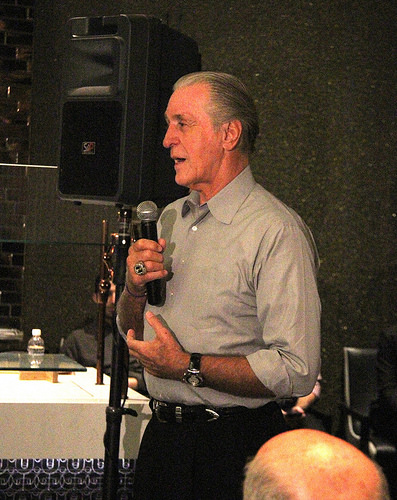<image>
Can you confirm if the speaker is behind the microphone? Yes. From this viewpoint, the speaker is positioned behind the microphone, with the microphone partially or fully occluding the speaker. 